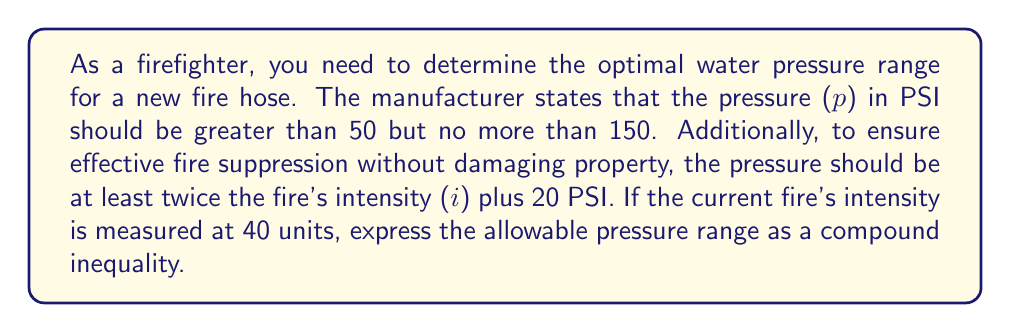What is the answer to this math problem? Let's approach this step-by-step:

1) First, we need to translate the given information into mathematical inequalities:

   a) The pressure should be greater than 50 PSI but no more than 150 PSI:
      $50 < p \leq 150$

   b) The pressure should be at least twice the fire's intensity plus 20 PSI:
      $p \geq 2i + 20$

2) We're given that the current fire's intensity (i) is 40 units. Let's substitute this into the second inequality:
   $p \geq 2(40) + 20$
   $p \geq 80 + 20$
   $p \geq 100$

3) Now we have two inequalities that need to be satisfied simultaneously:
   $50 < p \leq 150$
   $p \geq 100$

4) To combine these into a compound inequality, we need to find the overlap. The lower bound will be the larger of the two lower bounds (100 is greater than 50), and the upper bound remains 150:

   $100 \leq p \leq 150$

This compound inequality represents the allowable pressure range that satisfies all the given conditions.
Answer: $100 \leq p \leq 150$ 